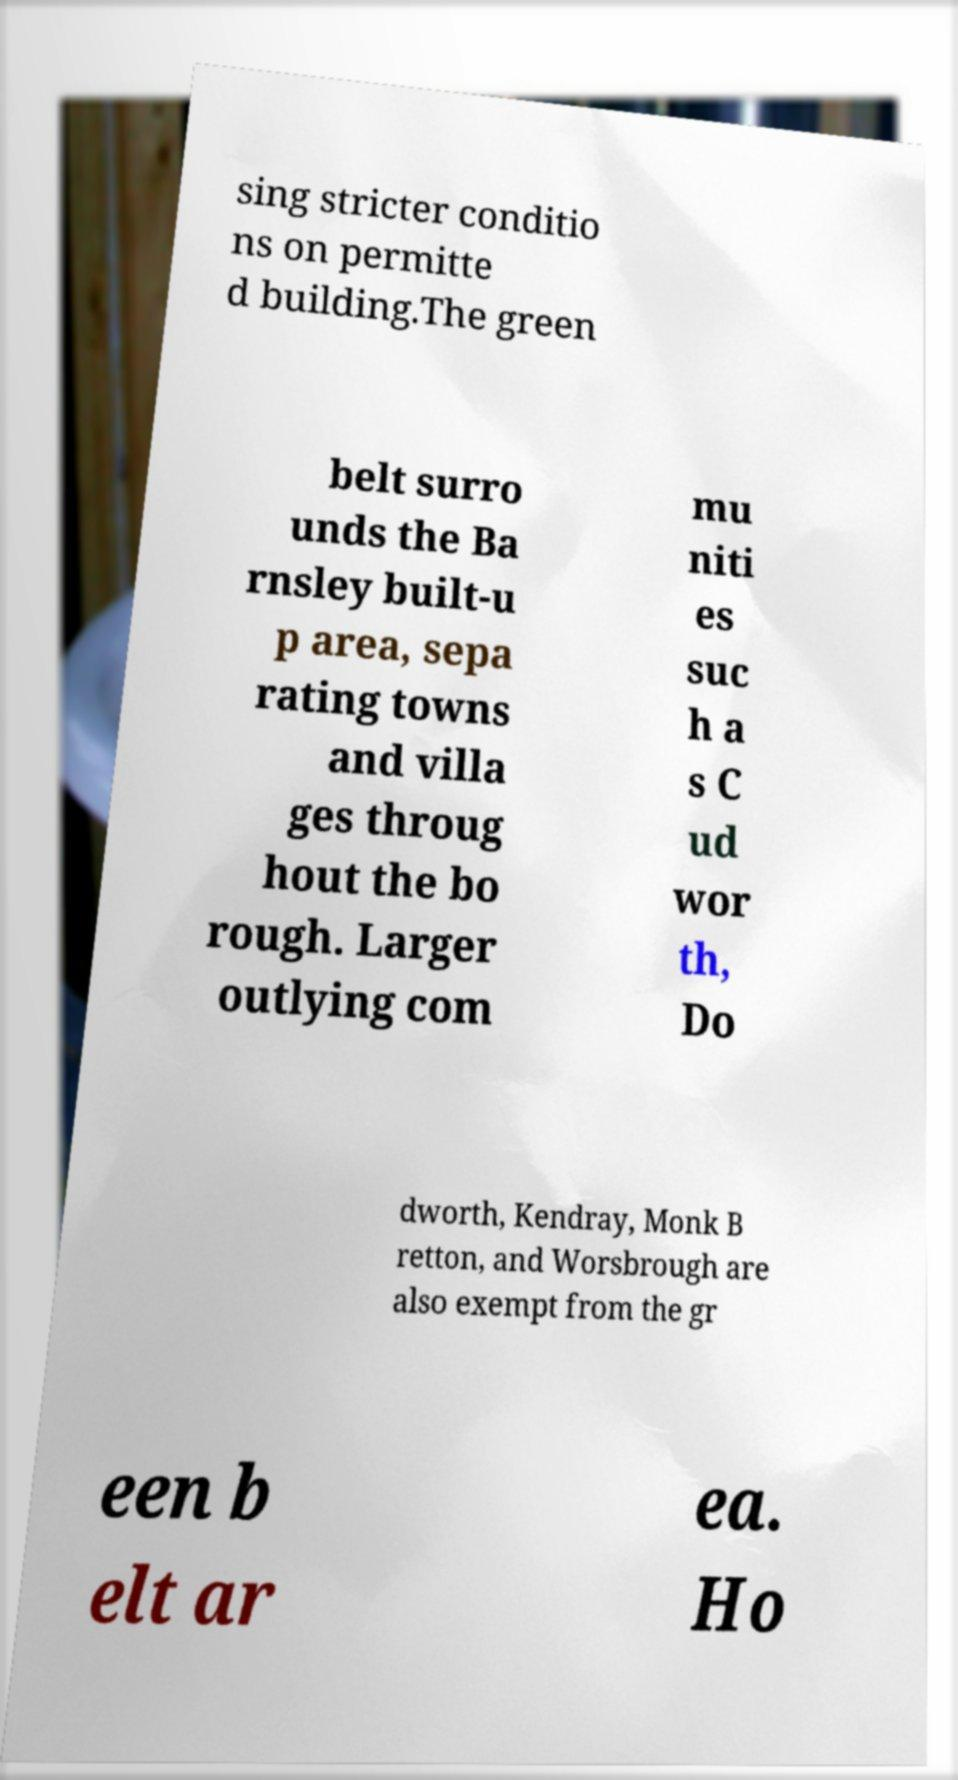For documentation purposes, I need the text within this image transcribed. Could you provide that? sing stricter conditio ns on permitte d building.The green belt surro unds the Ba rnsley built-u p area, sepa rating towns and villa ges throug hout the bo rough. Larger outlying com mu niti es suc h a s C ud wor th, Do dworth, Kendray, Monk B retton, and Worsbrough are also exempt from the gr een b elt ar ea. Ho 